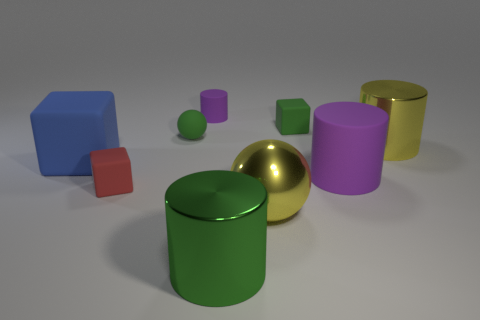There is a small green rubber object right of the tiny ball; is its shape the same as the small red rubber object?
Your answer should be very brief. Yes. What is the color of the small matte object that is the same shape as the big purple thing?
Make the answer very short. Purple. There is a green metallic object; is its shape the same as the big object behind the blue cube?
Offer a terse response. Yes. What size is the blue thing that is the same shape as the tiny red thing?
Provide a short and direct response. Large. Is the number of small red objects behind the tiny purple rubber object less than the number of tiny green rubber things that are behind the blue rubber cube?
Give a very brief answer. Yes. The small cube that is to the left of the shiny ball is what color?
Offer a very short reply. Red. How many other things are the same color as the rubber sphere?
Give a very brief answer. 2. There is a metal ball that is left of the green cube; is its size the same as the red matte object?
Keep it short and to the point. No. There is a yellow shiny sphere; how many big green cylinders are left of it?
Offer a terse response. 1. Are there any objects of the same size as the green rubber cube?
Your answer should be compact. Yes. 